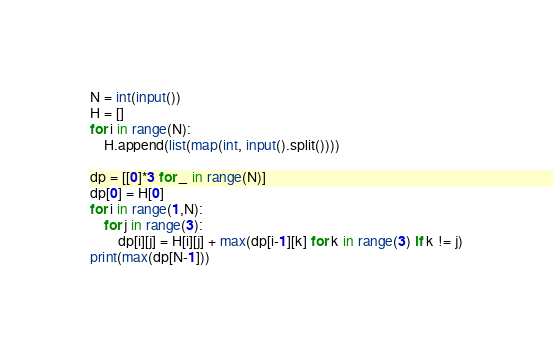<code> <loc_0><loc_0><loc_500><loc_500><_Python_>N = int(input())
H = []
for i in range(N):
    H.append(list(map(int, input().split())))

dp = [[0]*3 for _ in range(N)]
dp[0] = H[0]
for i in range(1,N):
    for j in range(3):
        dp[i][j] = H[i][j] + max(dp[i-1][k] for k in range(3) if k != j)
print(max(dp[N-1]))</code> 